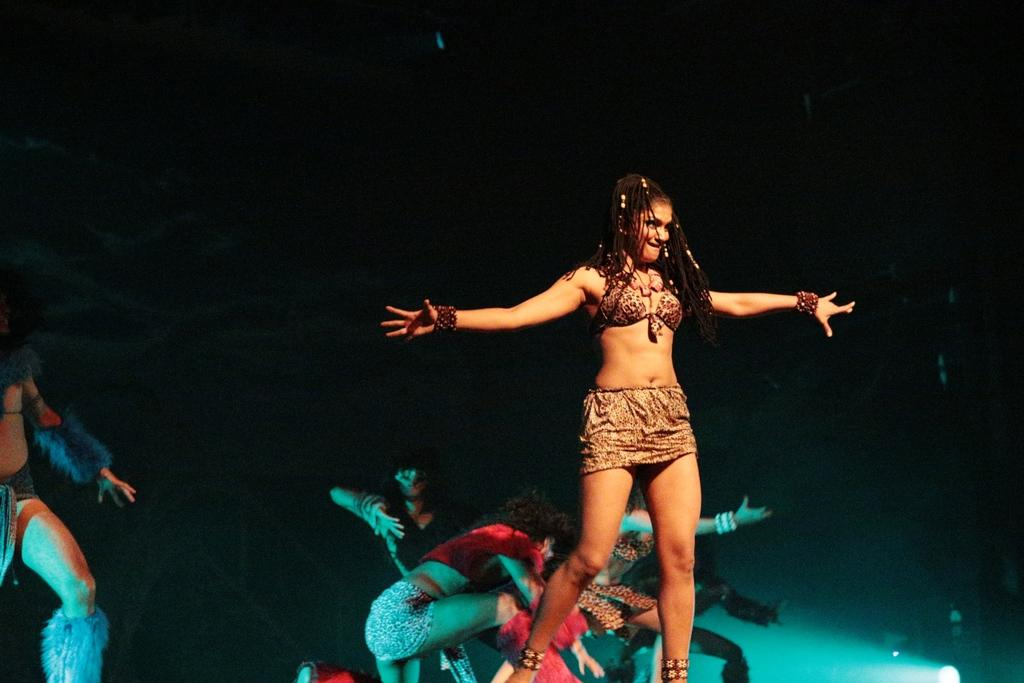What is the main subject of the image? There is a beautiful woman in the image. What is the woman doing in the image? The woman is dancing. What is the woman wearing in the image? The woman is wearing a dress. Are there any other people in the image? Yes, there are other people dancing in the image. What type of business is being conducted in the image? There is no indication of any business being conducted in the image; it features a woman and other people dancing. Can you see any ghosts in the image? There are no ghosts present in the image; it features a woman and other people dancing. 